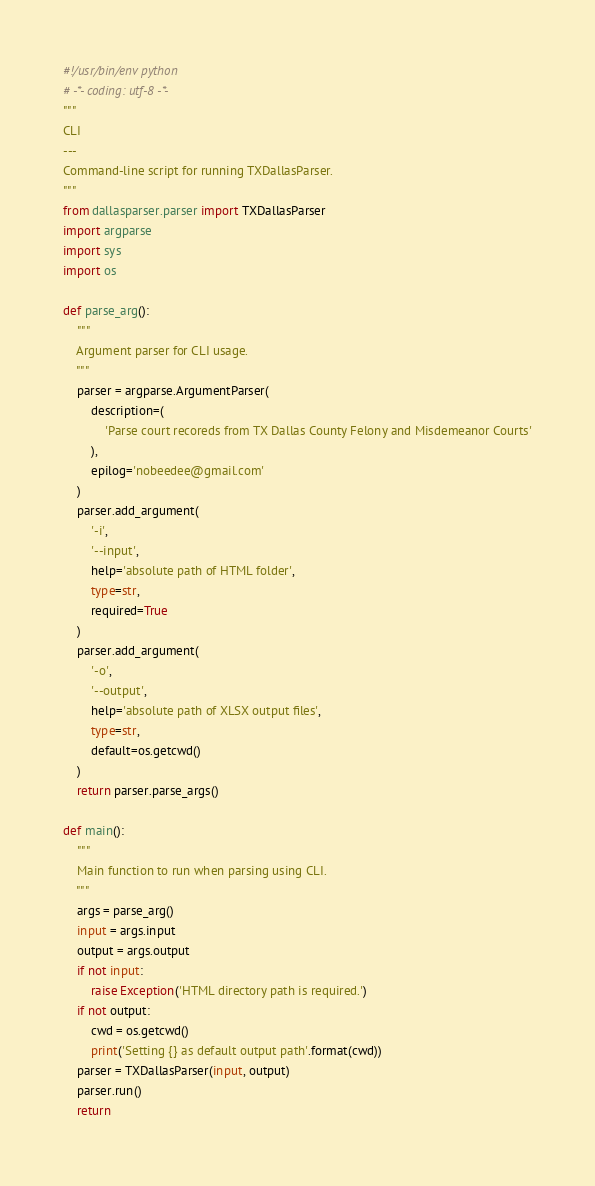<code> <loc_0><loc_0><loc_500><loc_500><_Python_>#!/usr/bin/env python
# -*- coding: utf-8 -*-
"""
CLI
---
Command-line script for running TXDallasParser.
"""
from dallasparser.parser import TXDallasParser
import argparse
import sys
import os

def parse_arg():
    """
    Argument parser for CLI usage.
    """
    parser = argparse.ArgumentParser(
        description=(
            'Parse court recoreds from TX Dallas County Felony and Misdemeanor Courts'
        ),
        epilog='nobeedee@gmail.com'
    )
    parser.add_argument(
        '-i',
        '--input',
        help='absolute path of HTML folder',
        type=str,
        required=True
    )
    parser.add_argument(
        '-o',
        '--output',
        help='absolute path of XLSX output files',
        type=str,
        default=os.getcwd()
    )
    return parser.parse_args()

def main():
    """
    Main function to run when parsing using CLI.
    """
    args = parse_arg()
    input = args.input
    output = args.output
    if not input:
        raise Exception('HTML directory path is required.')
    if not output:
        cwd = os.getcwd()
        print('Setting {} as default output path'.format(cwd))
    parser = TXDallasParser(input, output)
    parser.run()
    return
</code> 